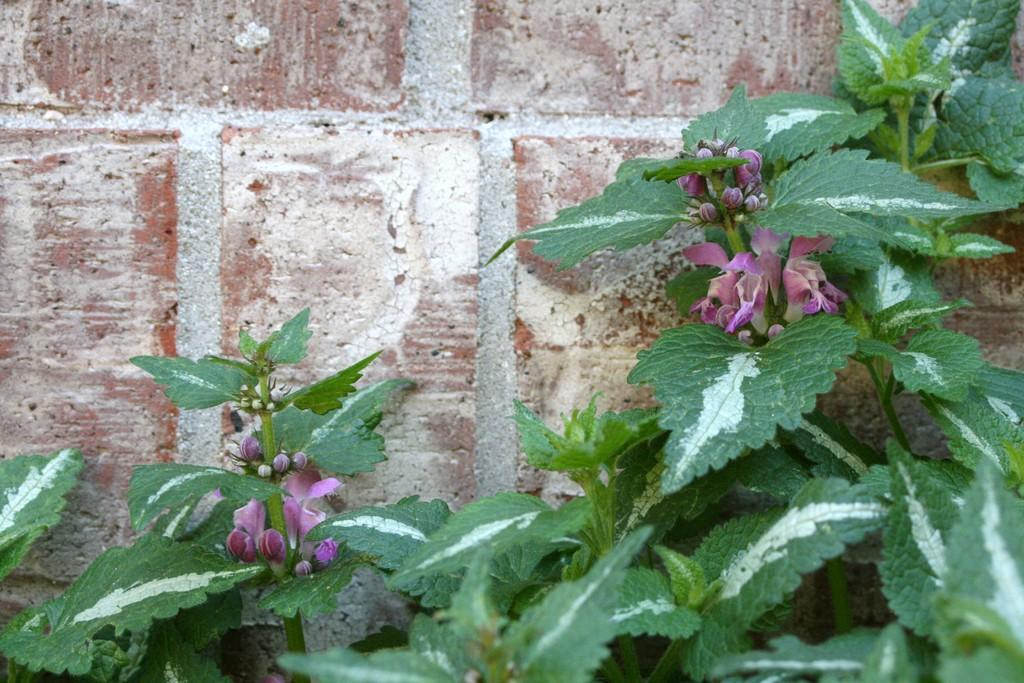What type of living organisms can be seen in the image? Plants can be seen in the image. What stage of growth are the plants in? The plants have buds and flowers. What colors are the flowers? The flowers are violet and purple in color. What is visible in the background of the image? There is a wall in the background of the image. What type of payment is accepted for the soda in the image? There is no soda or payment mentioned in the image; it features plants with buds and flowers. How much butter is visible on the plants in the image? There is no butter present in the image; it only features plants with buds and flowers. 